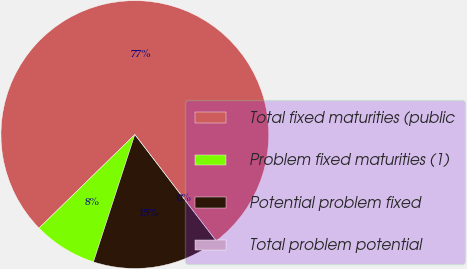<chart> <loc_0><loc_0><loc_500><loc_500><pie_chart><fcel>Total fixed maturities (public<fcel>Problem fixed maturities (1)<fcel>Potential problem fixed<fcel>Total problem potential<nl><fcel>76.92%<fcel>7.69%<fcel>15.39%<fcel>0.0%<nl></chart> 